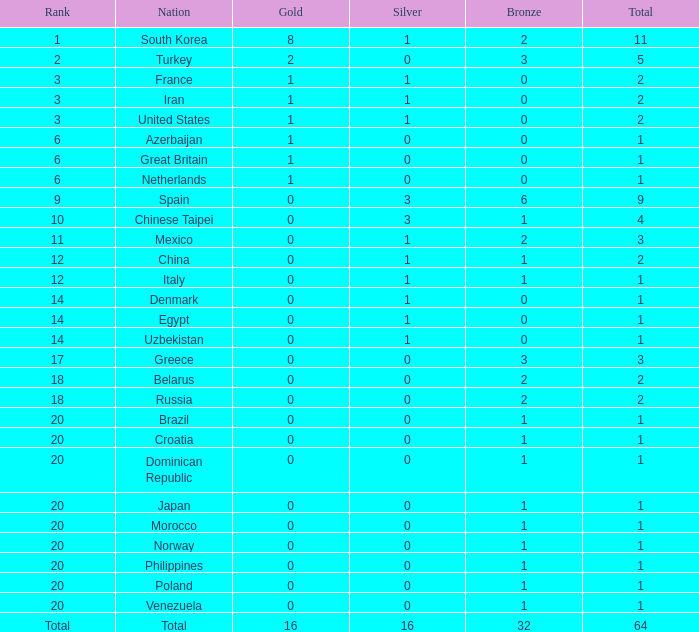What is the total number of silver medals russia possesses? 1.0. 